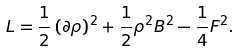<formula> <loc_0><loc_0><loc_500><loc_500>L = \frac { 1 } { 2 } \left ( \partial \rho \right ) ^ { 2 } + \frac { 1 } { 2 } \rho ^ { 2 } B ^ { 2 } - \frac { 1 } { 4 } F ^ { 2 } .</formula> 